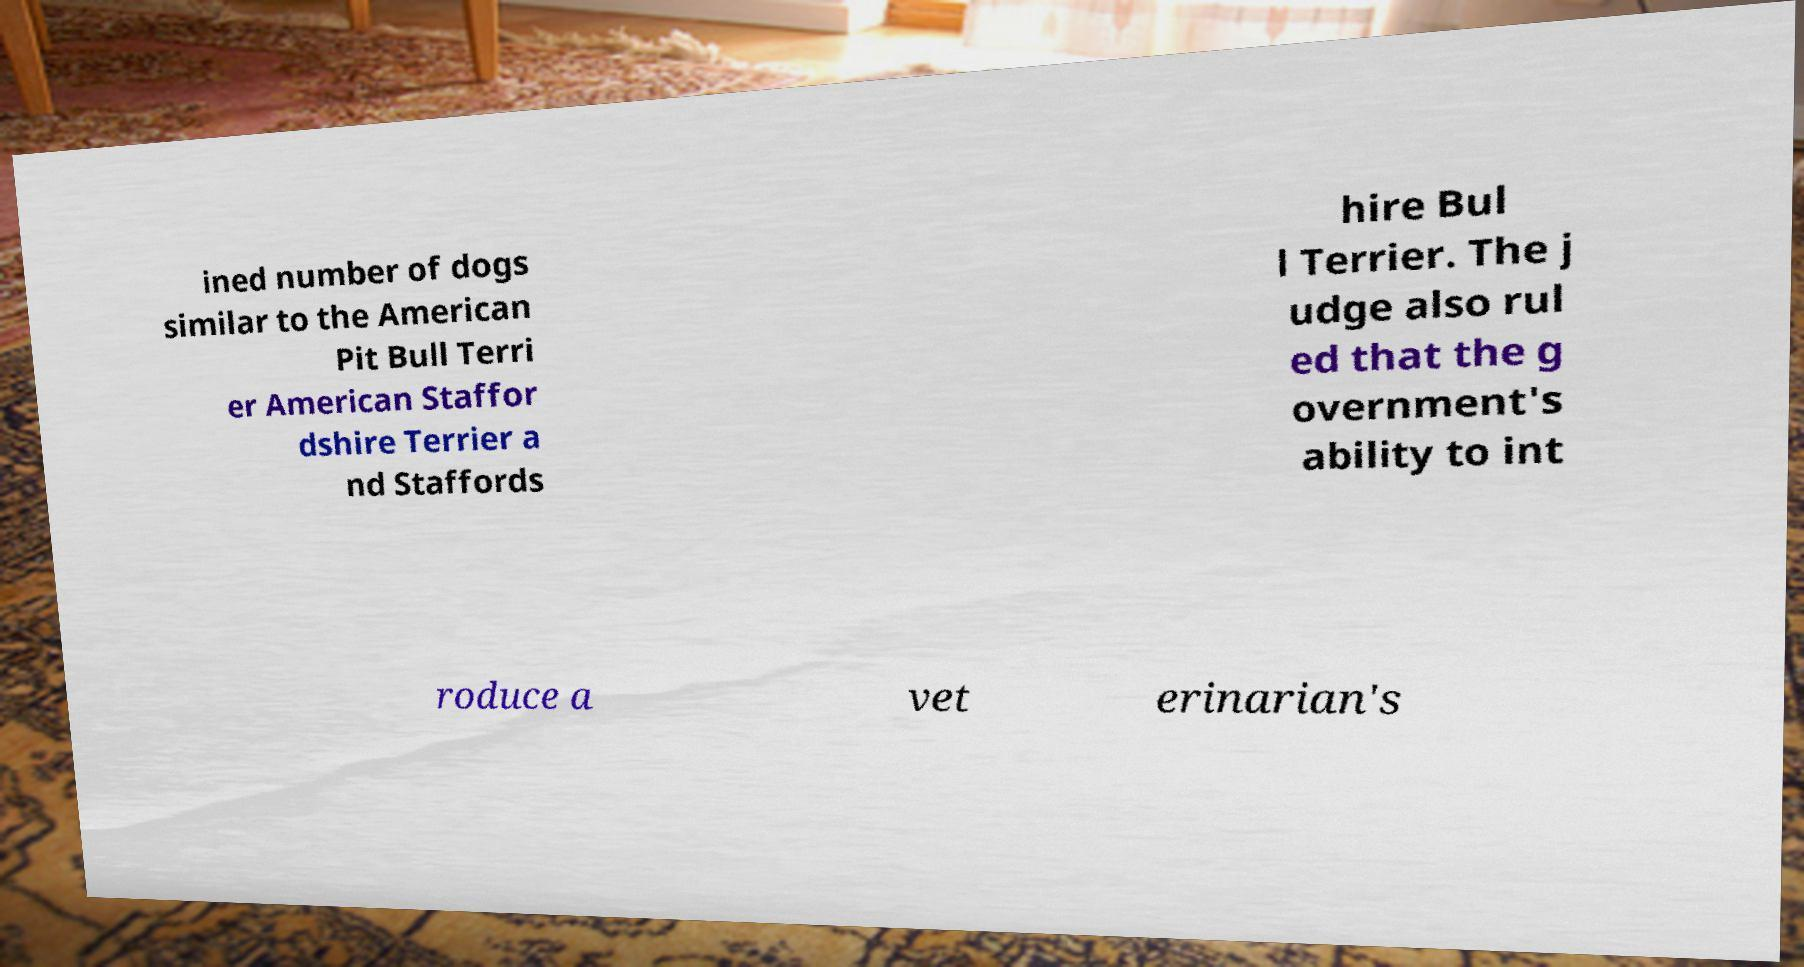For documentation purposes, I need the text within this image transcribed. Could you provide that? ined number of dogs similar to the American Pit Bull Terri er American Staffor dshire Terrier a nd Staffords hire Bul l Terrier. The j udge also rul ed that the g overnment's ability to int roduce a vet erinarian's 